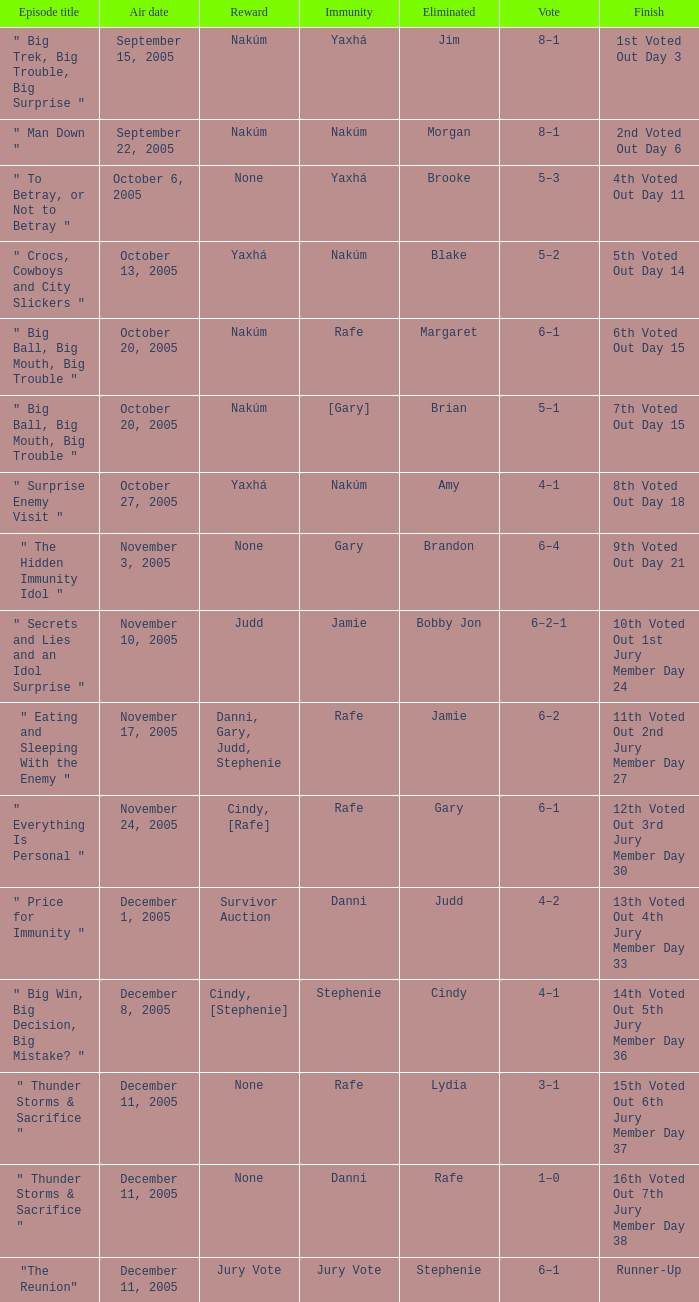How many prizes are there for air date october 6, 2005? None. 